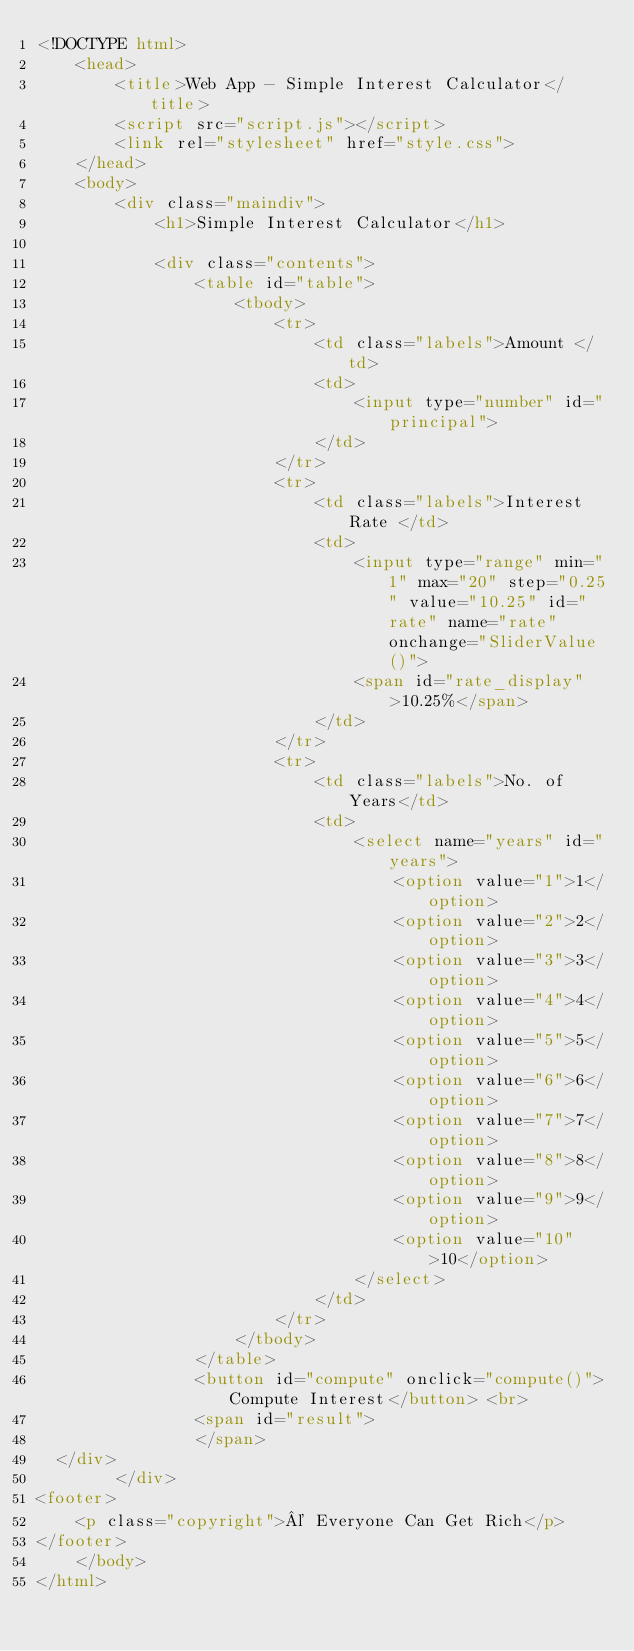Convert code to text. <code><loc_0><loc_0><loc_500><loc_500><_HTML_><!DOCTYPE html>
    <head>
        <title>Web App - Simple Interest Calculator</title>
        <script src="script.js"></script>
        <link rel="stylesheet" href="style.css">
    </head>
    <body>
        <div class="maindiv">
            <h1>Simple Interest Calculator</h1>

            <div class="contents">
                <table id="table">
                    <tbody>
                        <tr>
                            <td class="labels">Amount </td>
                            <td>
                                <input type="number" id="principal">
                            </td>
                        </tr>
                        <tr>
                            <td class="labels">Interest Rate </td>
                            <td>
                                <input type="range" min="1" max="20" step="0.25" value="10.25" id="rate" name="rate" onchange="SliderValue()"> 
                                <span id="rate_display">10.25%</span>
                            </td>
                        </tr>
                        <tr>
                            <td class="labels">No. of Years</td>
                            <td>
                                <select name="years" id="years">
                                    <option value="1">1</option>
                                    <option value="2">2</option>
                                    <option value="3">3</option>
                                    <option value="4">4</option>
                                    <option value="5">5</option>
                                    <option value="6">6</option>
                                    <option value="7">7</option>
                                    <option value="8">8</option>
                                    <option value="9">9</option>
                                    <option value="10">10</option>
                                </select>
                            </td>
                        </tr>
                    </tbody>
                </table>    
                <button id="compute" onclick="compute()">Compute Interest</button> <br>
                <span id="result">
                </span>
  </div>           
        </div>
<footer>    
    <p class="copyright">© Everyone Can Get Rich</p>
</footer>
    </body>
</html>
</code> 